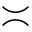Convert formula to latex. <formula><loc_0><loc_0><loc_500><loc_500>\asymp</formula> 